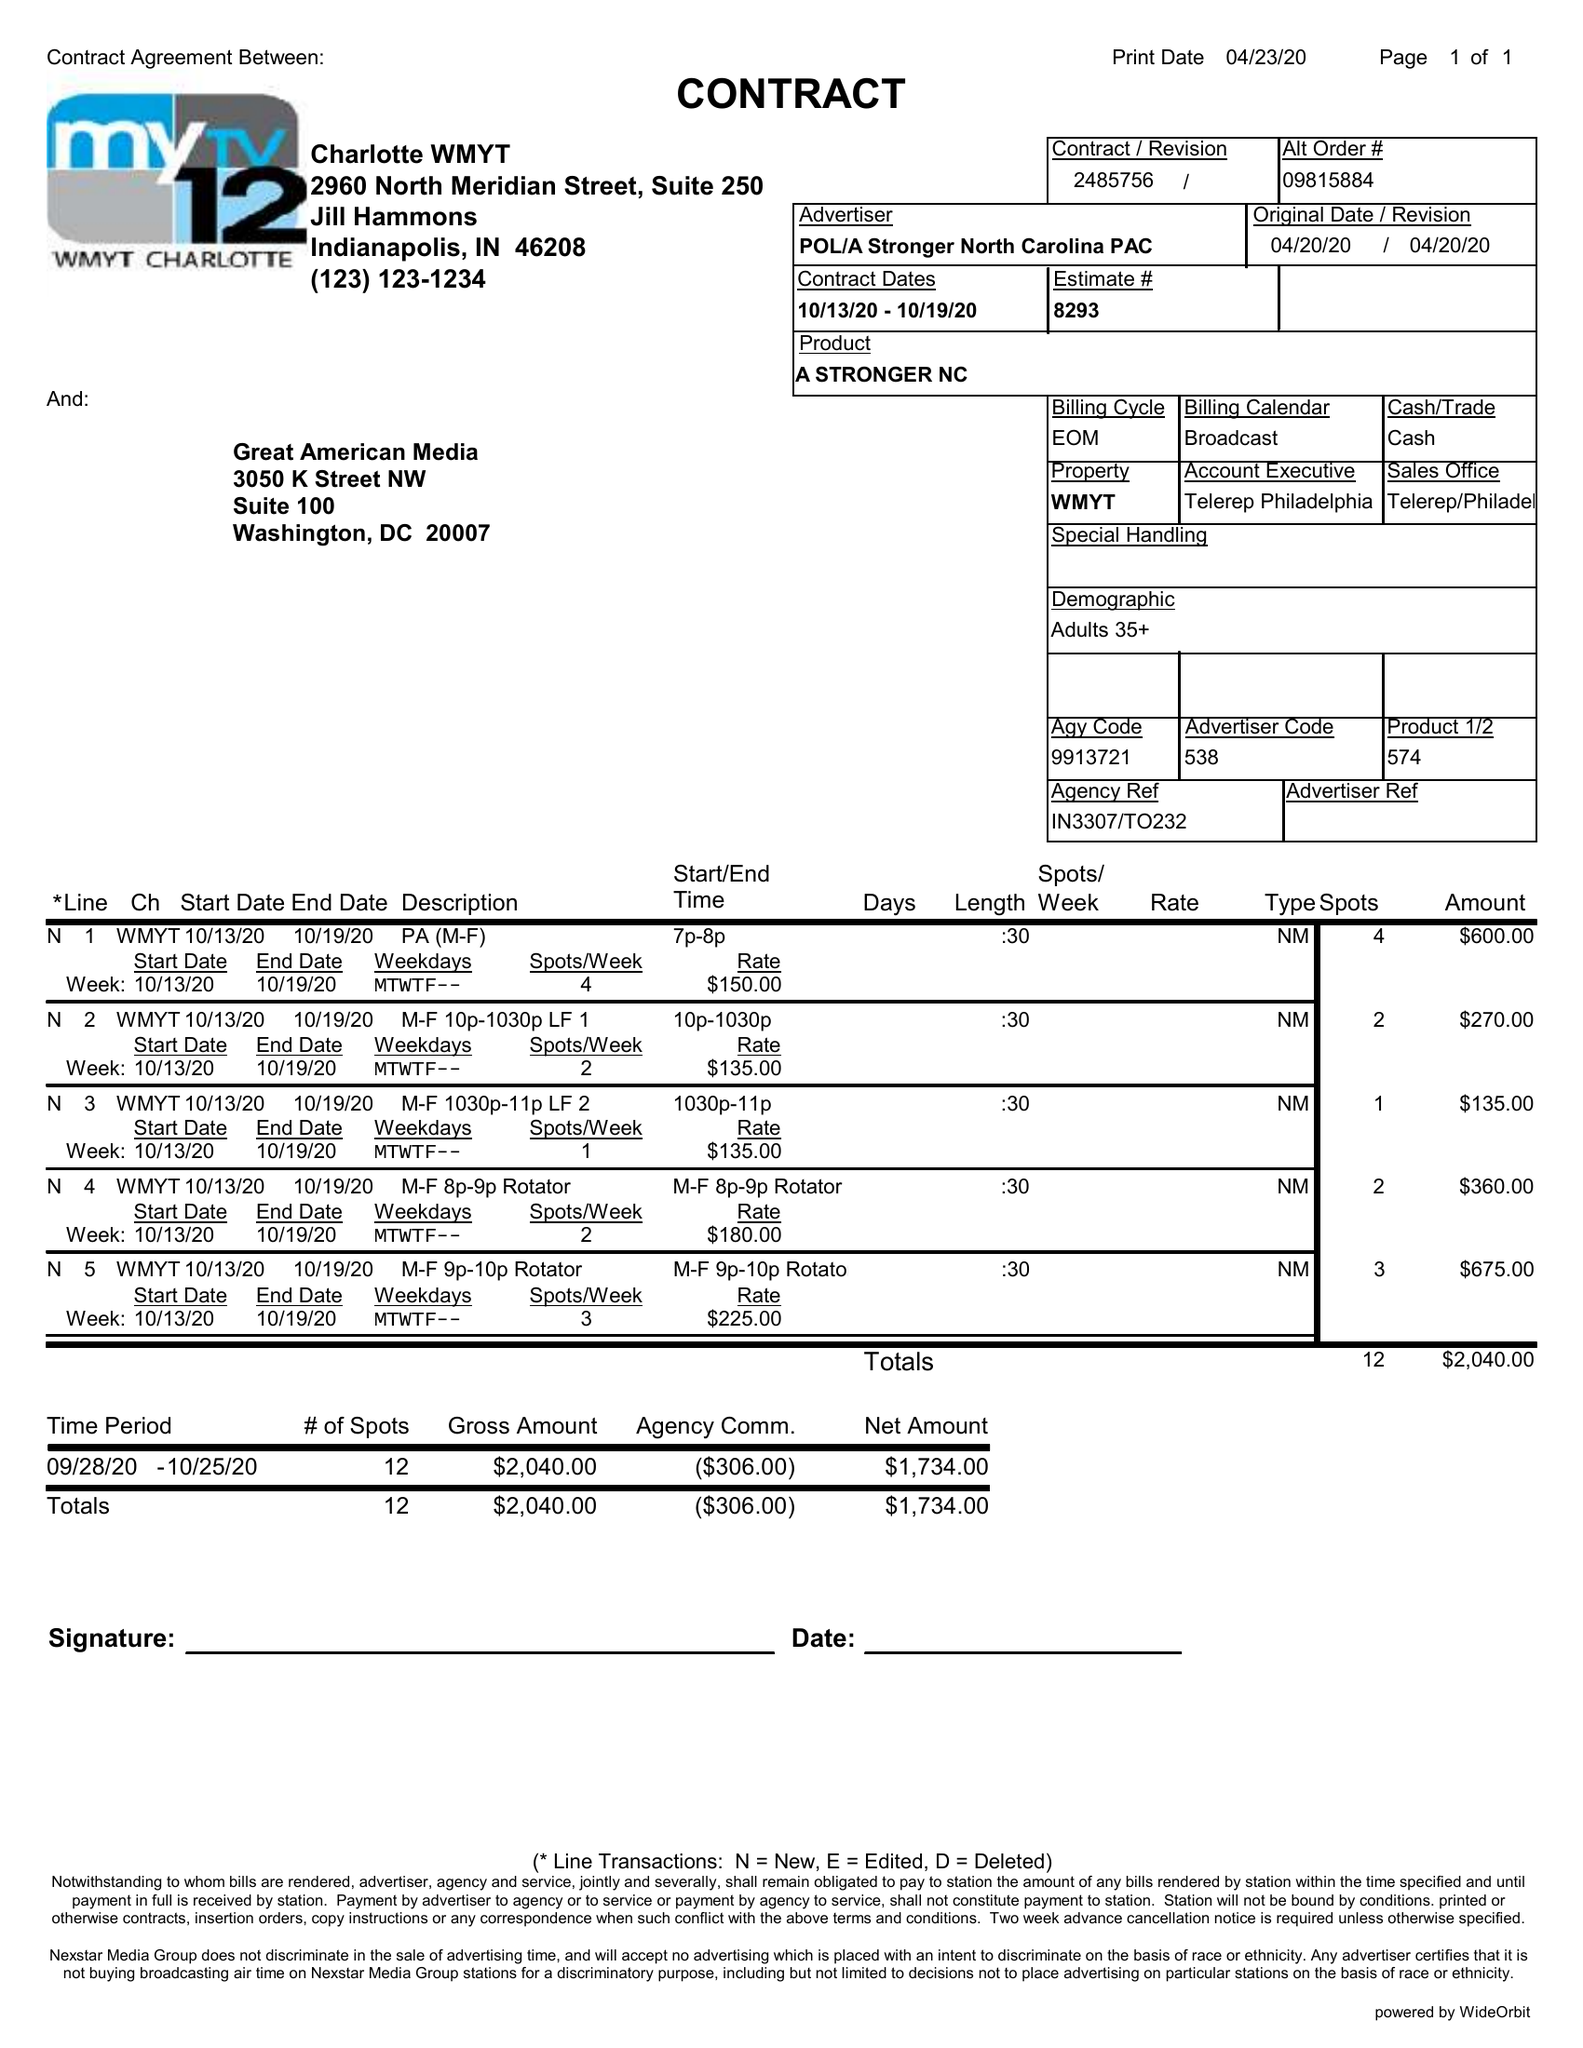What is the value for the contract_num?
Answer the question using a single word or phrase. 2485756 